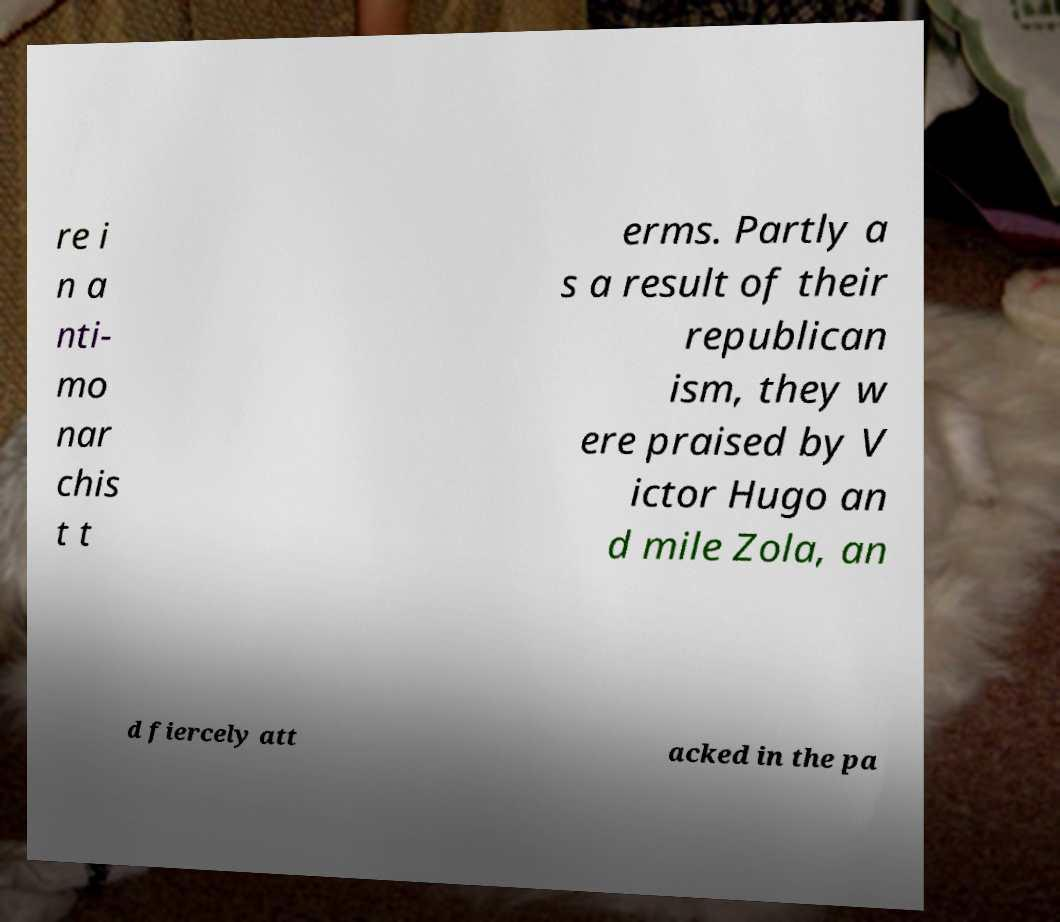I need the written content from this picture converted into text. Can you do that? re i n a nti- mo nar chis t t erms. Partly a s a result of their republican ism, they w ere praised by V ictor Hugo an d mile Zola, an d fiercely att acked in the pa 